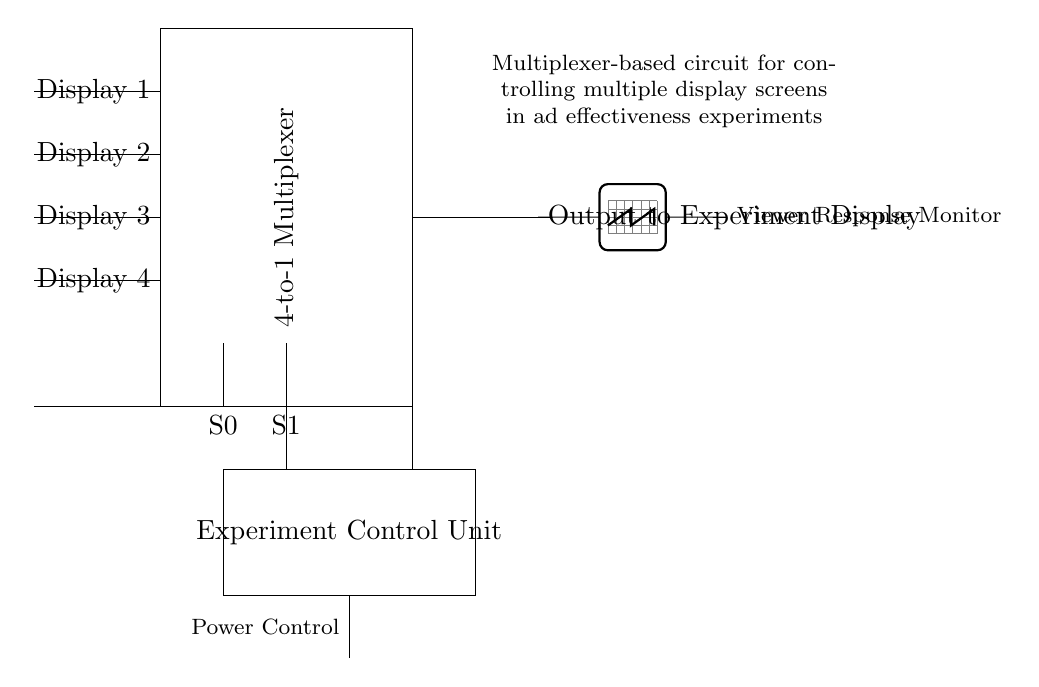What type of multiplexer is used in this circuit? The circuit diagram specifies a "4-to-1 Multiplexer," indicating that it has four input lines and one output line.
Answer: 4-to-1 Multiplexer What is the role of the select lines S0 and S1? The select lines S0 and S1 are used to choose which of the four input displays is connected to the output. Based on the values of these select lines, one of the inputs is routed to the output.
Answer: To choose the input display How many display inputs does this circuit have? The circuit shows four distinct input lines for displays labeled "Display 1" to "Display 4," indicating that there are four inputs available.
Answer: Four What is located at the output of the multiplexer? The output of the multiplexer connects to the "Experiment Display," which is part of the ad effectiveness experiments intended for monitoring viewer responses.
Answer: Output to Experiment Display What component monitors the viewer's response in this circuit? An "Oscilloscope" is shown connected to the output, which is used for monitoring the viewer response, indicating it measures and displays signals from the experiment.
Answer: Viewer Response Monitor Why is there a power control component in this circuit? The power control component is included to manage the power supply to the multiplexer and other components, ensuring proper operation of the circuit during experiments.
Answer: To manage power supply What does the experiment control unit do? The experiment control unit orchestrates the operation of the entire circuit by sending control signals to the multiplexer based on experimental requirements, coordinating the selected display.
Answer: It orchestrates the circuit operation 